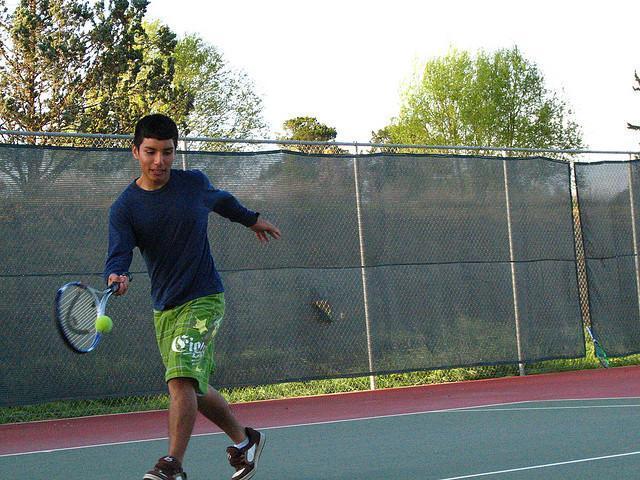How many hands is on the racket?
Give a very brief answer. 1. How many tennis rackets are visible?
Give a very brief answer. 1. 